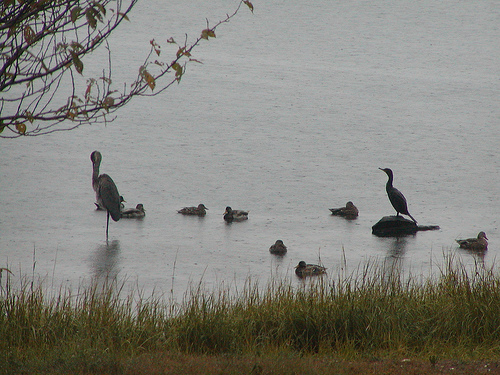<image>
Can you confirm if the duck is on the grass? No. The duck is not positioned on the grass. They may be near each other, but the duck is not supported by or resting on top of the grass. Is there a bird above the water? Yes. The bird is positioned above the water in the vertical space, higher up in the scene. 